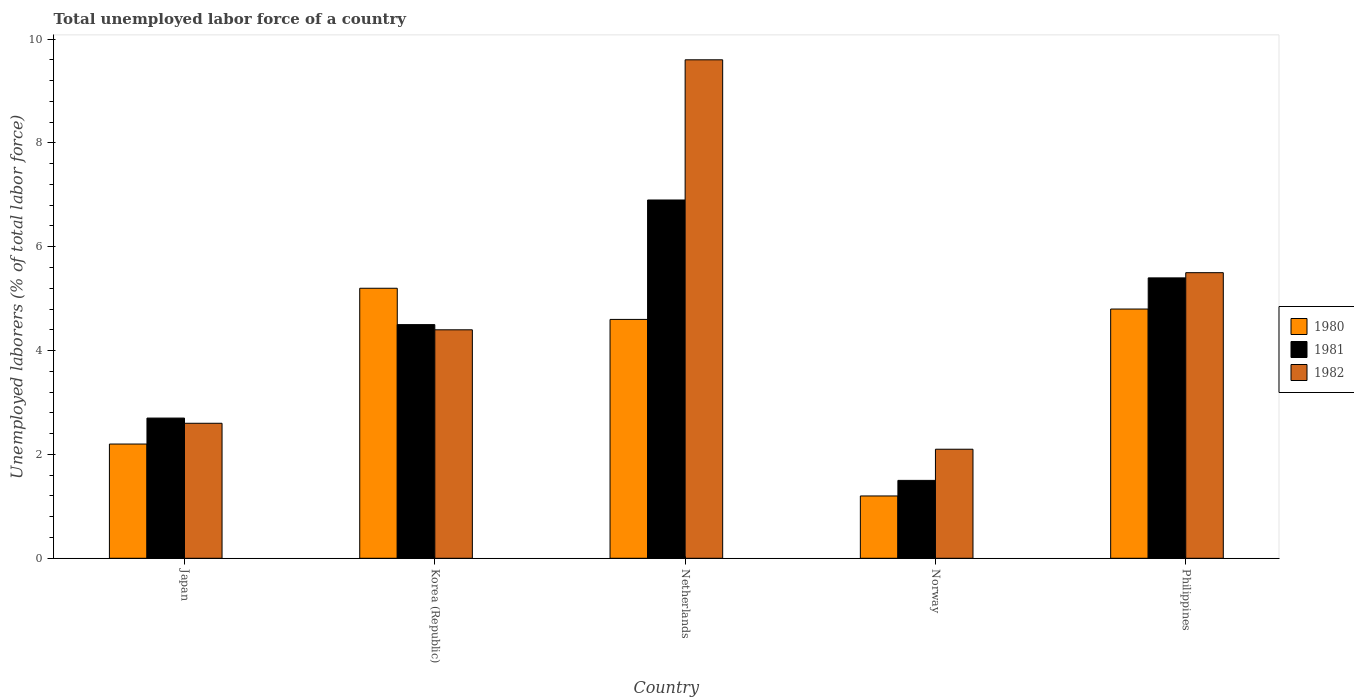How many bars are there on the 3rd tick from the right?
Provide a succinct answer. 3. Across all countries, what is the maximum total unemployed labor force in 1980?
Offer a very short reply. 5.2. Across all countries, what is the minimum total unemployed labor force in 1980?
Provide a succinct answer. 1.2. In which country was the total unemployed labor force in 1982 maximum?
Your response must be concise. Netherlands. What is the total total unemployed labor force in 1982 in the graph?
Keep it short and to the point. 24.2. What is the difference between the total unemployed labor force in 1980 in Netherlands and that in Norway?
Make the answer very short. 3.4. What is the difference between the total unemployed labor force in 1980 in Philippines and the total unemployed labor force in 1982 in Japan?
Make the answer very short. 2.2. What is the average total unemployed labor force in 1982 per country?
Give a very brief answer. 4.84. What is the difference between the total unemployed labor force of/in 1980 and total unemployed labor force of/in 1981 in Korea (Republic)?
Offer a terse response. 0.7. In how many countries, is the total unemployed labor force in 1981 greater than 9.2 %?
Your answer should be very brief. 0. What is the ratio of the total unemployed labor force in 1980 in Netherlands to that in Philippines?
Give a very brief answer. 0.96. Is the total unemployed labor force in 1981 in Japan less than that in Philippines?
Ensure brevity in your answer.  Yes. Is the difference between the total unemployed labor force in 1980 in Korea (Republic) and Norway greater than the difference between the total unemployed labor force in 1981 in Korea (Republic) and Norway?
Offer a very short reply. Yes. What is the difference between the highest and the second highest total unemployed labor force in 1980?
Your answer should be compact. -0.4. What is the difference between the highest and the lowest total unemployed labor force in 1982?
Keep it short and to the point. 7.5. In how many countries, is the total unemployed labor force in 1981 greater than the average total unemployed labor force in 1981 taken over all countries?
Your answer should be compact. 3. Is the sum of the total unemployed labor force in 1980 in Japan and Philippines greater than the maximum total unemployed labor force in 1982 across all countries?
Provide a succinct answer. No. What does the 2nd bar from the left in Philippines represents?
Provide a succinct answer. 1981. What does the 2nd bar from the right in Netherlands represents?
Your answer should be compact. 1981. Are all the bars in the graph horizontal?
Make the answer very short. No. What is the difference between two consecutive major ticks on the Y-axis?
Offer a very short reply. 2. Does the graph contain any zero values?
Give a very brief answer. No. Does the graph contain grids?
Your answer should be very brief. No. What is the title of the graph?
Your response must be concise. Total unemployed labor force of a country. What is the label or title of the X-axis?
Your answer should be very brief. Country. What is the label or title of the Y-axis?
Keep it short and to the point. Unemployed laborers (% of total labor force). What is the Unemployed laborers (% of total labor force) in 1980 in Japan?
Provide a short and direct response. 2.2. What is the Unemployed laborers (% of total labor force) of 1981 in Japan?
Ensure brevity in your answer.  2.7. What is the Unemployed laborers (% of total labor force) in 1982 in Japan?
Provide a short and direct response. 2.6. What is the Unemployed laborers (% of total labor force) of 1980 in Korea (Republic)?
Give a very brief answer. 5.2. What is the Unemployed laborers (% of total labor force) in 1981 in Korea (Republic)?
Keep it short and to the point. 4.5. What is the Unemployed laborers (% of total labor force) of 1982 in Korea (Republic)?
Keep it short and to the point. 4.4. What is the Unemployed laborers (% of total labor force) in 1980 in Netherlands?
Ensure brevity in your answer.  4.6. What is the Unemployed laborers (% of total labor force) in 1981 in Netherlands?
Your answer should be compact. 6.9. What is the Unemployed laborers (% of total labor force) in 1982 in Netherlands?
Make the answer very short. 9.6. What is the Unemployed laborers (% of total labor force) of 1980 in Norway?
Your answer should be compact. 1.2. What is the Unemployed laborers (% of total labor force) of 1981 in Norway?
Your answer should be very brief. 1.5. What is the Unemployed laborers (% of total labor force) in 1982 in Norway?
Ensure brevity in your answer.  2.1. What is the Unemployed laborers (% of total labor force) in 1980 in Philippines?
Your answer should be very brief. 4.8. What is the Unemployed laborers (% of total labor force) of 1981 in Philippines?
Your response must be concise. 5.4. Across all countries, what is the maximum Unemployed laborers (% of total labor force) in 1980?
Give a very brief answer. 5.2. Across all countries, what is the maximum Unemployed laborers (% of total labor force) in 1981?
Give a very brief answer. 6.9. Across all countries, what is the maximum Unemployed laborers (% of total labor force) in 1982?
Give a very brief answer. 9.6. Across all countries, what is the minimum Unemployed laborers (% of total labor force) in 1980?
Make the answer very short. 1.2. Across all countries, what is the minimum Unemployed laborers (% of total labor force) in 1981?
Provide a succinct answer. 1.5. Across all countries, what is the minimum Unemployed laborers (% of total labor force) in 1982?
Your response must be concise. 2.1. What is the total Unemployed laborers (% of total labor force) of 1980 in the graph?
Your answer should be compact. 18. What is the total Unemployed laborers (% of total labor force) in 1982 in the graph?
Offer a terse response. 24.2. What is the difference between the Unemployed laborers (% of total labor force) of 1980 in Japan and that in Korea (Republic)?
Your response must be concise. -3. What is the difference between the Unemployed laborers (% of total labor force) of 1981 in Japan and that in Korea (Republic)?
Your answer should be compact. -1.8. What is the difference between the Unemployed laborers (% of total labor force) of 1980 in Japan and that in Netherlands?
Your answer should be very brief. -2.4. What is the difference between the Unemployed laborers (% of total labor force) in 1981 in Japan and that in Netherlands?
Your answer should be compact. -4.2. What is the difference between the Unemployed laborers (% of total labor force) of 1982 in Japan and that in Netherlands?
Your answer should be very brief. -7. What is the difference between the Unemployed laborers (% of total labor force) of 1980 in Japan and that in Norway?
Make the answer very short. 1. What is the difference between the Unemployed laborers (% of total labor force) of 1981 in Japan and that in Norway?
Provide a succinct answer. 1.2. What is the difference between the Unemployed laborers (% of total labor force) in 1982 in Japan and that in Norway?
Provide a short and direct response. 0.5. What is the difference between the Unemployed laborers (% of total labor force) of 1980 in Japan and that in Philippines?
Keep it short and to the point. -2.6. What is the difference between the Unemployed laborers (% of total labor force) of 1981 in Japan and that in Philippines?
Make the answer very short. -2.7. What is the difference between the Unemployed laborers (% of total labor force) of 1980 in Korea (Republic) and that in Netherlands?
Keep it short and to the point. 0.6. What is the difference between the Unemployed laborers (% of total labor force) of 1982 in Korea (Republic) and that in Netherlands?
Your answer should be compact. -5.2. What is the difference between the Unemployed laborers (% of total labor force) of 1981 in Korea (Republic) and that in Norway?
Provide a succinct answer. 3. What is the difference between the Unemployed laborers (% of total labor force) of 1980 in Korea (Republic) and that in Philippines?
Make the answer very short. 0.4. What is the difference between the Unemployed laborers (% of total labor force) in 1981 in Korea (Republic) and that in Philippines?
Offer a terse response. -0.9. What is the difference between the Unemployed laborers (% of total labor force) in 1980 in Netherlands and that in Norway?
Your response must be concise. 3.4. What is the difference between the Unemployed laborers (% of total labor force) of 1981 in Netherlands and that in Norway?
Your response must be concise. 5.4. What is the difference between the Unemployed laborers (% of total labor force) of 1981 in Netherlands and that in Philippines?
Make the answer very short. 1.5. What is the difference between the Unemployed laborers (% of total labor force) of 1980 in Norway and that in Philippines?
Your answer should be very brief. -3.6. What is the difference between the Unemployed laborers (% of total labor force) of 1981 in Norway and that in Philippines?
Your answer should be very brief. -3.9. What is the difference between the Unemployed laborers (% of total labor force) of 1982 in Norway and that in Philippines?
Provide a succinct answer. -3.4. What is the difference between the Unemployed laborers (% of total labor force) of 1980 in Japan and the Unemployed laborers (% of total labor force) of 1981 in Korea (Republic)?
Provide a short and direct response. -2.3. What is the difference between the Unemployed laborers (% of total labor force) of 1981 in Japan and the Unemployed laborers (% of total labor force) of 1982 in Norway?
Ensure brevity in your answer.  0.6. What is the difference between the Unemployed laborers (% of total labor force) in 1980 in Japan and the Unemployed laborers (% of total labor force) in 1982 in Philippines?
Provide a succinct answer. -3.3. What is the difference between the Unemployed laborers (% of total labor force) of 1980 in Korea (Republic) and the Unemployed laborers (% of total labor force) of 1981 in Netherlands?
Offer a terse response. -1.7. What is the difference between the Unemployed laborers (% of total labor force) in 1980 in Korea (Republic) and the Unemployed laborers (% of total labor force) in 1982 in Netherlands?
Give a very brief answer. -4.4. What is the difference between the Unemployed laborers (% of total labor force) of 1981 in Korea (Republic) and the Unemployed laborers (% of total labor force) of 1982 in Netherlands?
Your answer should be very brief. -5.1. What is the difference between the Unemployed laborers (% of total labor force) of 1980 in Korea (Republic) and the Unemployed laborers (% of total labor force) of 1982 in Norway?
Offer a terse response. 3.1. What is the difference between the Unemployed laborers (% of total labor force) in 1980 in Korea (Republic) and the Unemployed laborers (% of total labor force) in 1981 in Philippines?
Make the answer very short. -0.2. What is the difference between the Unemployed laborers (% of total labor force) in 1980 in Korea (Republic) and the Unemployed laborers (% of total labor force) in 1982 in Philippines?
Give a very brief answer. -0.3. What is the difference between the Unemployed laborers (% of total labor force) in 1981 in Korea (Republic) and the Unemployed laborers (% of total labor force) in 1982 in Philippines?
Provide a succinct answer. -1. What is the difference between the Unemployed laborers (% of total labor force) of 1980 in Netherlands and the Unemployed laborers (% of total labor force) of 1981 in Norway?
Your answer should be very brief. 3.1. What is the difference between the Unemployed laborers (% of total labor force) in 1980 in Netherlands and the Unemployed laborers (% of total labor force) in 1981 in Philippines?
Make the answer very short. -0.8. What is the difference between the Unemployed laborers (% of total labor force) in 1980 in Norway and the Unemployed laborers (% of total labor force) in 1982 in Philippines?
Offer a terse response. -4.3. What is the average Unemployed laborers (% of total labor force) in 1981 per country?
Offer a very short reply. 4.2. What is the average Unemployed laborers (% of total labor force) in 1982 per country?
Provide a succinct answer. 4.84. What is the difference between the Unemployed laborers (% of total labor force) in 1980 and Unemployed laborers (% of total labor force) in 1981 in Japan?
Your answer should be compact. -0.5. What is the difference between the Unemployed laborers (% of total labor force) of 1980 and Unemployed laborers (% of total labor force) of 1982 in Japan?
Give a very brief answer. -0.4. What is the difference between the Unemployed laborers (% of total labor force) of 1981 and Unemployed laborers (% of total labor force) of 1982 in Japan?
Provide a short and direct response. 0.1. What is the difference between the Unemployed laborers (% of total labor force) in 1980 and Unemployed laborers (% of total labor force) in 1981 in Korea (Republic)?
Provide a short and direct response. 0.7. What is the difference between the Unemployed laborers (% of total labor force) of 1980 and Unemployed laborers (% of total labor force) of 1981 in Netherlands?
Make the answer very short. -2.3. What is the difference between the Unemployed laborers (% of total labor force) in 1981 and Unemployed laborers (% of total labor force) in 1982 in Netherlands?
Provide a succinct answer. -2.7. What is the difference between the Unemployed laborers (% of total labor force) of 1980 and Unemployed laborers (% of total labor force) of 1981 in Philippines?
Your answer should be very brief. -0.6. What is the ratio of the Unemployed laborers (% of total labor force) in 1980 in Japan to that in Korea (Republic)?
Give a very brief answer. 0.42. What is the ratio of the Unemployed laborers (% of total labor force) in 1981 in Japan to that in Korea (Republic)?
Give a very brief answer. 0.6. What is the ratio of the Unemployed laborers (% of total labor force) of 1982 in Japan to that in Korea (Republic)?
Ensure brevity in your answer.  0.59. What is the ratio of the Unemployed laborers (% of total labor force) of 1980 in Japan to that in Netherlands?
Offer a very short reply. 0.48. What is the ratio of the Unemployed laborers (% of total labor force) in 1981 in Japan to that in Netherlands?
Keep it short and to the point. 0.39. What is the ratio of the Unemployed laborers (% of total labor force) of 1982 in Japan to that in Netherlands?
Offer a very short reply. 0.27. What is the ratio of the Unemployed laborers (% of total labor force) in 1980 in Japan to that in Norway?
Ensure brevity in your answer.  1.83. What is the ratio of the Unemployed laborers (% of total labor force) in 1982 in Japan to that in Norway?
Your answer should be very brief. 1.24. What is the ratio of the Unemployed laborers (% of total labor force) of 1980 in Japan to that in Philippines?
Provide a succinct answer. 0.46. What is the ratio of the Unemployed laborers (% of total labor force) in 1981 in Japan to that in Philippines?
Provide a short and direct response. 0.5. What is the ratio of the Unemployed laborers (% of total labor force) in 1982 in Japan to that in Philippines?
Your answer should be compact. 0.47. What is the ratio of the Unemployed laborers (% of total labor force) of 1980 in Korea (Republic) to that in Netherlands?
Ensure brevity in your answer.  1.13. What is the ratio of the Unemployed laborers (% of total labor force) of 1981 in Korea (Republic) to that in Netherlands?
Offer a very short reply. 0.65. What is the ratio of the Unemployed laborers (% of total labor force) in 1982 in Korea (Republic) to that in Netherlands?
Keep it short and to the point. 0.46. What is the ratio of the Unemployed laborers (% of total labor force) of 1980 in Korea (Republic) to that in Norway?
Provide a short and direct response. 4.33. What is the ratio of the Unemployed laborers (% of total labor force) in 1981 in Korea (Republic) to that in Norway?
Provide a succinct answer. 3. What is the ratio of the Unemployed laborers (% of total labor force) in 1982 in Korea (Republic) to that in Norway?
Your response must be concise. 2.1. What is the ratio of the Unemployed laborers (% of total labor force) of 1980 in Korea (Republic) to that in Philippines?
Your answer should be very brief. 1.08. What is the ratio of the Unemployed laborers (% of total labor force) of 1982 in Korea (Republic) to that in Philippines?
Make the answer very short. 0.8. What is the ratio of the Unemployed laborers (% of total labor force) in 1980 in Netherlands to that in Norway?
Give a very brief answer. 3.83. What is the ratio of the Unemployed laborers (% of total labor force) in 1981 in Netherlands to that in Norway?
Give a very brief answer. 4.6. What is the ratio of the Unemployed laborers (% of total labor force) in 1982 in Netherlands to that in Norway?
Give a very brief answer. 4.57. What is the ratio of the Unemployed laborers (% of total labor force) in 1980 in Netherlands to that in Philippines?
Your answer should be compact. 0.96. What is the ratio of the Unemployed laborers (% of total labor force) in 1981 in Netherlands to that in Philippines?
Keep it short and to the point. 1.28. What is the ratio of the Unemployed laborers (% of total labor force) of 1982 in Netherlands to that in Philippines?
Offer a very short reply. 1.75. What is the ratio of the Unemployed laborers (% of total labor force) of 1981 in Norway to that in Philippines?
Give a very brief answer. 0.28. What is the ratio of the Unemployed laborers (% of total labor force) of 1982 in Norway to that in Philippines?
Your response must be concise. 0.38. What is the difference between the highest and the second highest Unemployed laborers (% of total labor force) of 1980?
Your answer should be compact. 0.4. What is the difference between the highest and the second highest Unemployed laborers (% of total labor force) in 1981?
Provide a short and direct response. 1.5. What is the difference between the highest and the lowest Unemployed laborers (% of total labor force) of 1982?
Provide a succinct answer. 7.5. 